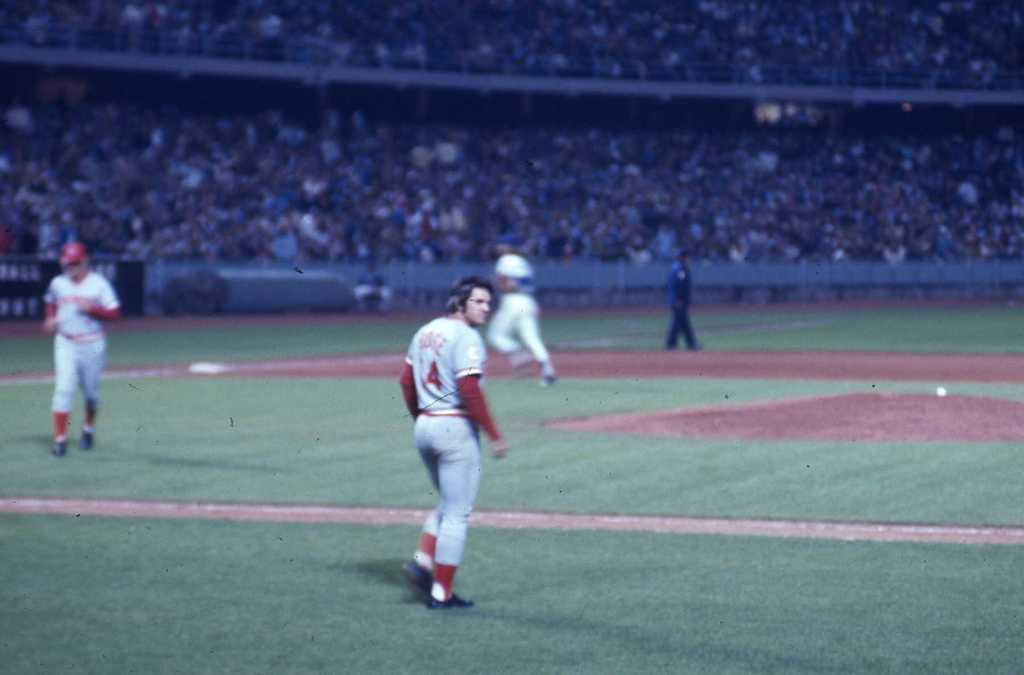<image>
Create a compact narrative representing the image presented. A baseball player wearing number 4 walks out to the field. 